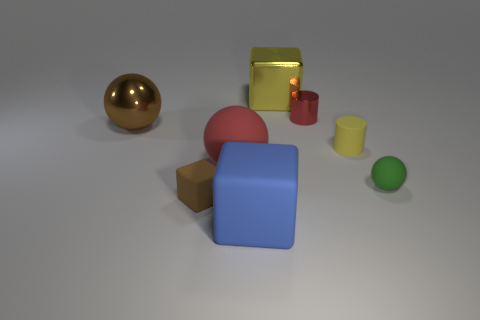There is a block that is made of the same material as the tiny red cylinder; what size is it?
Provide a succinct answer. Large. How many tiny matte cubes have the same color as the metal cube?
Give a very brief answer. 0. Are there fewer blocks in front of the tiny brown thing than blue objects that are right of the tiny yellow thing?
Provide a succinct answer. No. There is a yellow cylinder that is right of the brown rubber cube; what is its size?
Make the answer very short. Small. What size is the metallic thing that is the same color as the large rubber ball?
Make the answer very short. Small. Is there a large brown ball made of the same material as the large yellow cube?
Provide a short and direct response. Yes. Does the blue block have the same material as the tiny brown object?
Your response must be concise. Yes. Are there the same number of large brown metallic spheres and matte balls?
Make the answer very short. No. There is a metal cylinder that is the same size as the green ball; what color is it?
Your answer should be compact. Red. What number of other objects are there of the same shape as the small green thing?
Your answer should be very brief. 2. 